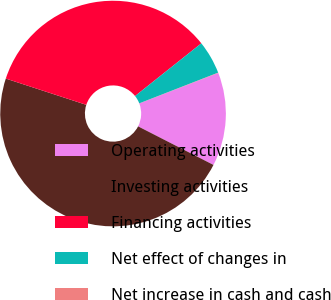Convert chart. <chart><loc_0><loc_0><loc_500><loc_500><pie_chart><fcel>Operating activities<fcel>Investing activities<fcel>Financing activities<fcel>Net effect of changes in<fcel>Net increase in cash and cash<nl><fcel>13.39%<fcel>47.49%<fcel>34.29%<fcel>4.79%<fcel>0.04%<nl></chart> 